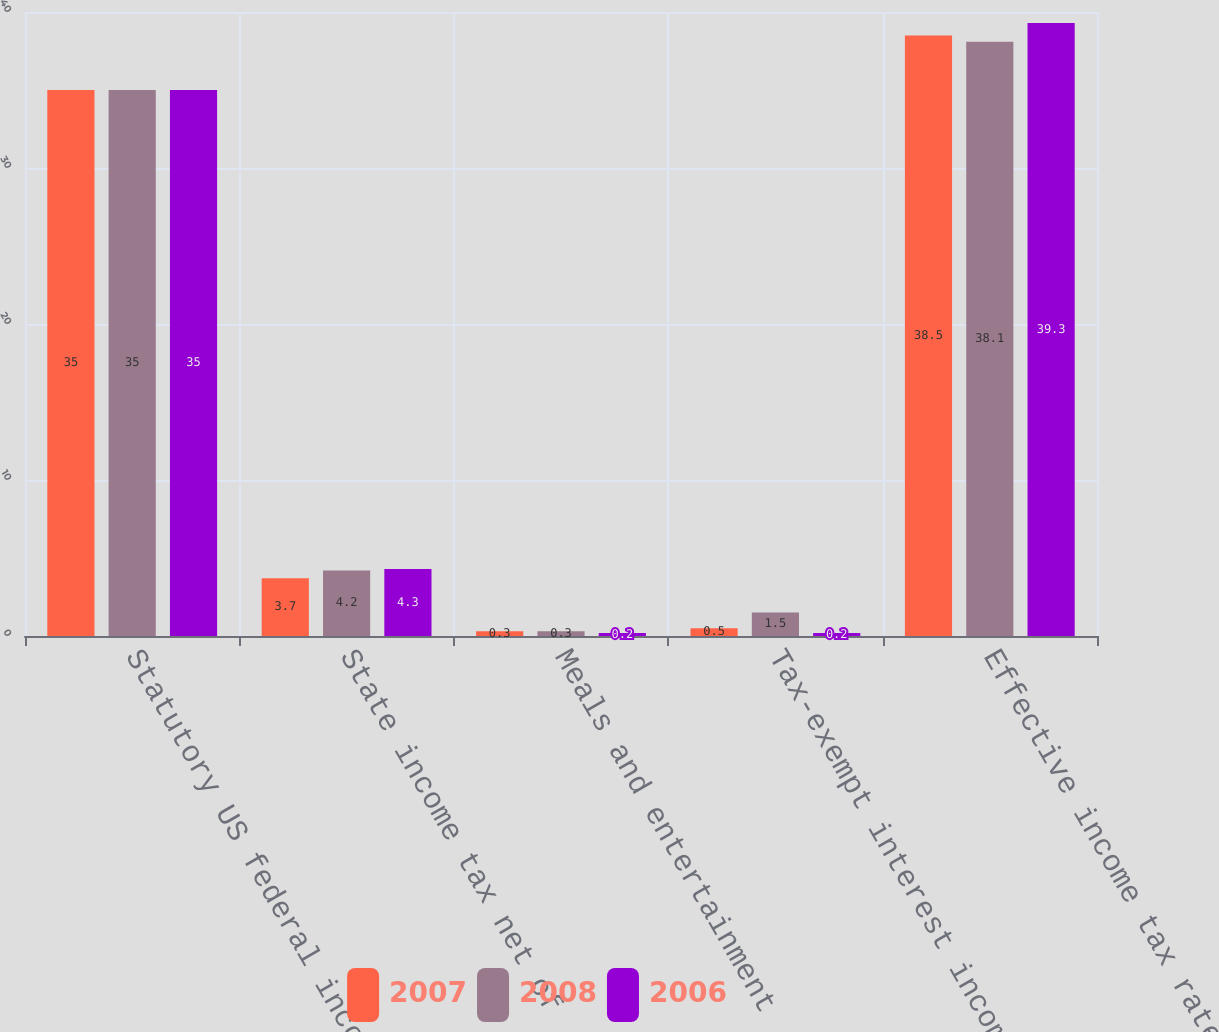Convert chart. <chart><loc_0><loc_0><loc_500><loc_500><stacked_bar_chart><ecel><fcel>Statutory US federal income<fcel>State income tax net of<fcel>Meals and entertainment<fcel>Tax-exempt interest income<fcel>Effective income tax rates<nl><fcel>2007<fcel>35<fcel>3.7<fcel>0.3<fcel>0.5<fcel>38.5<nl><fcel>2008<fcel>35<fcel>4.2<fcel>0.3<fcel>1.5<fcel>38.1<nl><fcel>2006<fcel>35<fcel>4.3<fcel>0.2<fcel>0.2<fcel>39.3<nl></chart> 